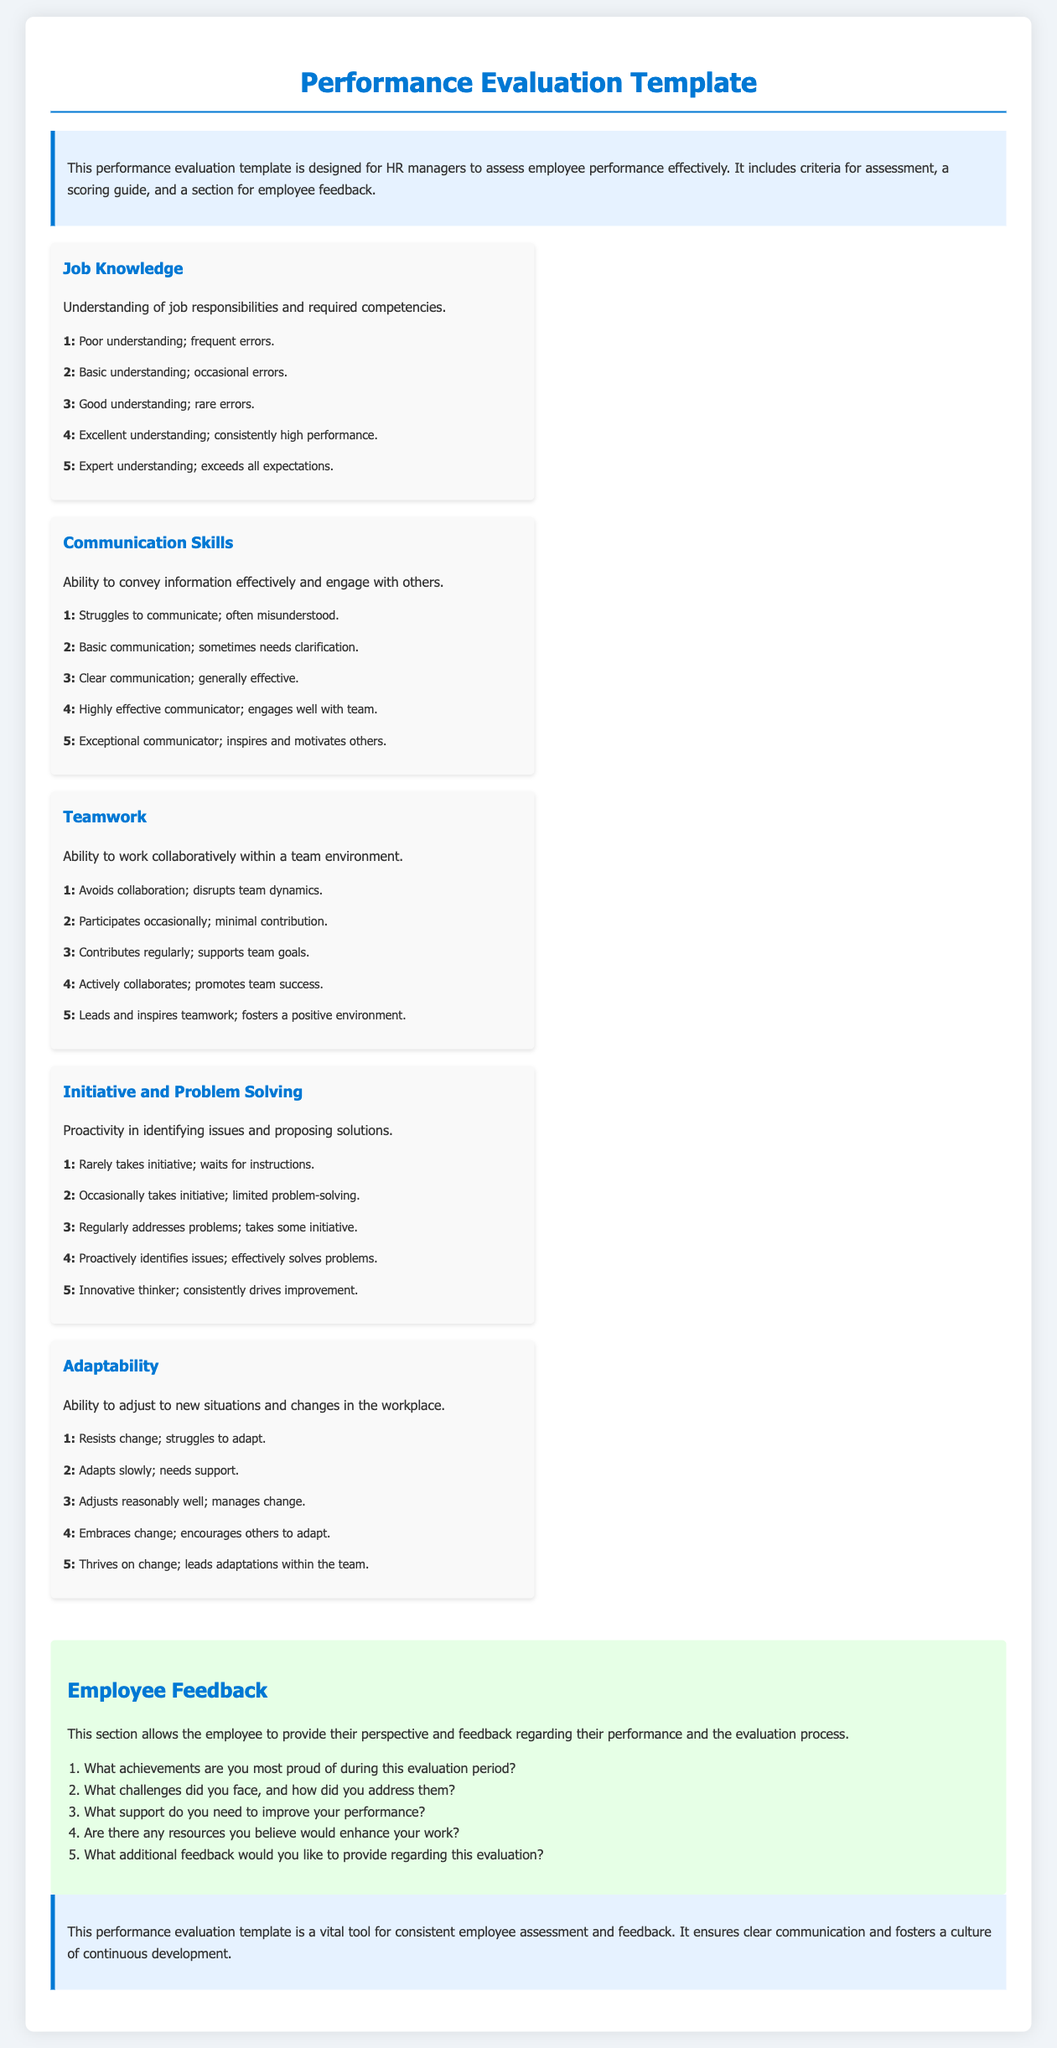What is the title of the document? The title of the document is found at the top of the document and indicates its purpose.
Answer: Performance Evaluation Template How many criteria for assessment are there? The criteria for assessment are listed in individual sections, which can be counted.
Answer: Five What is the highest score in the scoring guide? The scoring guide provides scores ranging from 1 to 5, where the highest score is specified.
Answer: Five What criterion involves understanding job responsibilities? The document specifies criteria that evaluate different aspects of employee performance.
Answer: Job Knowledge What does the feedback section allow employees to provide? The feedback section is explicitly designed for employees to share their thoughts and experiences.
Answer: Their perspective and feedback Which scoring criterion includes the ability to work collaboratively? Each criterion assesses a different skill or trait, one of which focuses on teamwork.
Answer: Teamwork What is the score for "Excellent understanding; consistently high performance"? The scoring guide assigns a specific number to describe performance levels clearly.
Answer: Four What does the introduction highlight as the template's main purpose? The introduction outlines the template's goal in the context of performance evaluation.
Answer: To assess employee performance effectively What is one of the feedback questions related to employee achievements? The feedback section contains questions aimed at understanding employee experiences and accomplishments.
Answer: What achievements are you most proud of during this evaluation period? 